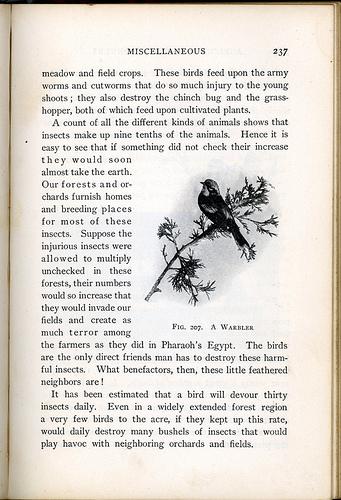Would it seem that this is a non-fiction book page?
Keep it brief. Yes. What colleges library Icelandic collection?
Keep it brief. None. What page is this?
Quick response, please. 237. What is the notation on the bottom of the picture?
Short answer required. Warbler. 